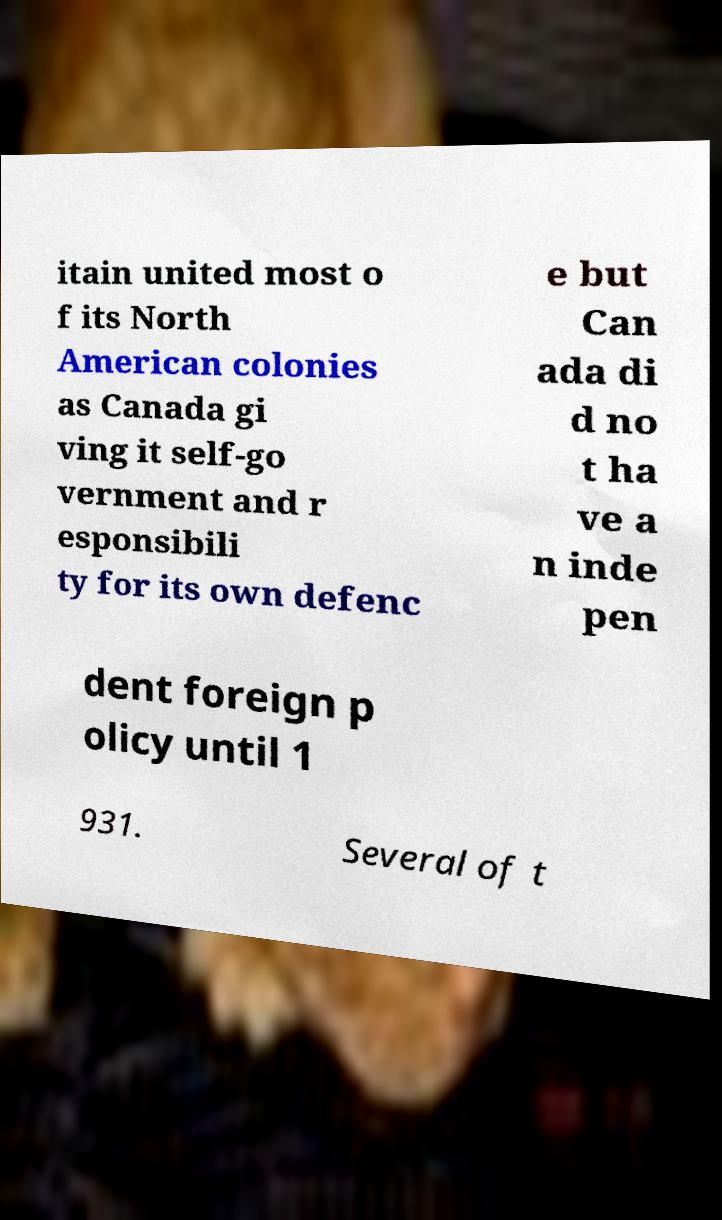Can you read and provide the text displayed in the image?This photo seems to have some interesting text. Can you extract and type it out for me? itain united most o f its North American colonies as Canada gi ving it self-go vernment and r esponsibili ty for its own defenc e but Can ada di d no t ha ve a n inde pen dent foreign p olicy until 1 931. Several of t 